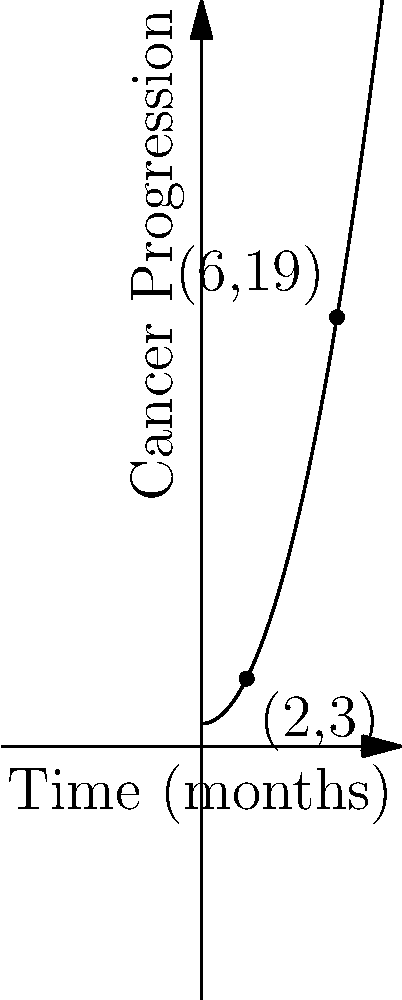A graph shows the progression of cancer over time, with two significant data points: (2,3) and (6,19). Find the equation of the line passing through these two points, which represents the average rate of cancer progression. What is the slope of this line? To find the equation of a line passing through two points, we can use the point-slope form of a line: $y - y_1 = m(x - x_1)$, where $m$ is the slope.

1. Calculate the slope $(m)$ using the two given points:
   $m = \frac{y_2 - y_1}{x_2 - x_1} = \frac{19 - 3}{6 - 2} = \frac{16}{4} = 4$

2. Use either point to write the equation. Let's use (2,3):
   $y - 3 = 4(x - 2)$

3. Expand the equation:
   $y - 3 = 4x - 8$

4. Solve for $y$ to get the slope-intercept form:
   $y = 4x - 5$

The slope of the line, which represents the average rate of cancer progression, is 4.
Answer: 4 